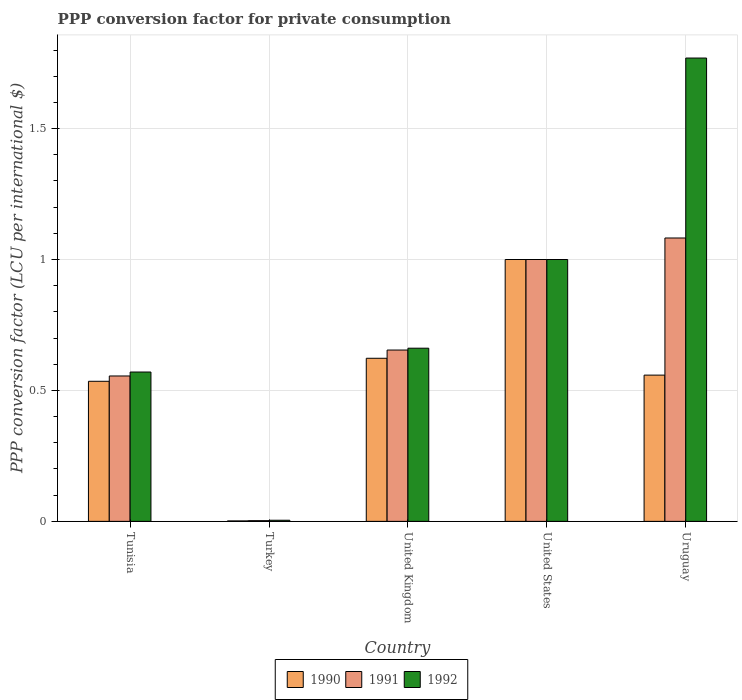Are the number of bars on each tick of the X-axis equal?
Offer a very short reply. Yes. How many bars are there on the 3rd tick from the right?
Your response must be concise. 3. What is the label of the 2nd group of bars from the left?
Your response must be concise. Turkey. What is the PPP conversion factor for private consumption in 1992 in Turkey?
Provide a short and direct response. 0. Across all countries, what is the maximum PPP conversion factor for private consumption in 1991?
Give a very brief answer. 1.08. Across all countries, what is the minimum PPP conversion factor for private consumption in 1990?
Your answer should be compact. 0. In which country was the PPP conversion factor for private consumption in 1992 maximum?
Your response must be concise. Uruguay. In which country was the PPP conversion factor for private consumption in 1992 minimum?
Provide a succinct answer. Turkey. What is the total PPP conversion factor for private consumption in 1992 in the graph?
Give a very brief answer. 4.01. What is the difference between the PPP conversion factor for private consumption in 1990 in Tunisia and that in Turkey?
Keep it short and to the point. 0.53. What is the difference between the PPP conversion factor for private consumption in 1991 in Uruguay and the PPP conversion factor for private consumption in 1992 in United States?
Offer a very short reply. 0.08. What is the average PPP conversion factor for private consumption in 1990 per country?
Your answer should be compact. 0.54. What is the difference between the PPP conversion factor for private consumption of/in 1991 and PPP conversion factor for private consumption of/in 1990 in United States?
Make the answer very short. 0. In how many countries, is the PPP conversion factor for private consumption in 1992 greater than 0.6 LCU?
Provide a short and direct response. 3. What is the ratio of the PPP conversion factor for private consumption in 1991 in Tunisia to that in Uruguay?
Your response must be concise. 0.51. What is the difference between the highest and the second highest PPP conversion factor for private consumption in 1991?
Provide a succinct answer. -0.43. What is the difference between the highest and the lowest PPP conversion factor for private consumption in 1992?
Your response must be concise. 1.77. Is the sum of the PPP conversion factor for private consumption in 1992 in Tunisia and United States greater than the maximum PPP conversion factor for private consumption in 1991 across all countries?
Your answer should be very brief. Yes. What does the 2nd bar from the left in Tunisia represents?
Your answer should be compact. 1991. What does the 1st bar from the right in United States represents?
Keep it short and to the point. 1992. Is it the case that in every country, the sum of the PPP conversion factor for private consumption in 1992 and PPP conversion factor for private consumption in 1991 is greater than the PPP conversion factor for private consumption in 1990?
Offer a terse response. Yes. How many bars are there?
Offer a very short reply. 15. How many countries are there in the graph?
Your answer should be very brief. 5. Does the graph contain any zero values?
Offer a very short reply. No. Where does the legend appear in the graph?
Your answer should be very brief. Bottom center. How many legend labels are there?
Provide a short and direct response. 3. What is the title of the graph?
Your answer should be compact. PPP conversion factor for private consumption. What is the label or title of the X-axis?
Your answer should be very brief. Country. What is the label or title of the Y-axis?
Make the answer very short. PPP conversion factor (LCU per international $). What is the PPP conversion factor (LCU per international $) in 1990 in Tunisia?
Offer a terse response. 0.53. What is the PPP conversion factor (LCU per international $) of 1991 in Tunisia?
Give a very brief answer. 0.56. What is the PPP conversion factor (LCU per international $) in 1992 in Tunisia?
Keep it short and to the point. 0.57. What is the PPP conversion factor (LCU per international $) in 1990 in Turkey?
Make the answer very short. 0. What is the PPP conversion factor (LCU per international $) in 1991 in Turkey?
Keep it short and to the point. 0. What is the PPP conversion factor (LCU per international $) of 1992 in Turkey?
Make the answer very short. 0. What is the PPP conversion factor (LCU per international $) in 1990 in United Kingdom?
Provide a succinct answer. 0.62. What is the PPP conversion factor (LCU per international $) of 1991 in United Kingdom?
Provide a succinct answer. 0.65. What is the PPP conversion factor (LCU per international $) in 1992 in United Kingdom?
Offer a terse response. 0.66. What is the PPP conversion factor (LCU per international $) in 1990 in United States?
Ensure brevity in your answer.  1. What is the PPP conversion factor (LCU per international $) of 1991 in United States?
Your answer should be compact. 1. What is the PPP conversion factor (LCU per international $) in 1992 in United States?
Provide a succinct answer. 1. What is the PPP conversion factor (LCU per international $) in 1990 in Uruguay?
Your answer should be compact. 0.56. What is the PPP conversion factor (LCU per international $) in 1991 in Uruguay?
Make the answer very short. 1.08. What is the PPP conversion factor (LCU per international $) of 1992 in Uruguay?
Offer a terse response. 1.77. Across all countries, what is the maximum PPP conversion factor (LCU per international $) in 1991?
Ensure brevity in your answer.  1.08. Across all countries, what is the maximum PPP conversion factor (LCU per international $) of 1992?
Ensure brevity in your answer.  1.77. Across all countries, what is the minimum PPP conversion factor (LCU per international $) in 1990?
Make the answer very short. 0. Across all countries, what is the minimum PPP conversion factor (LCU per international $) in 1991?
Keep it short and to the point. 0. Across all countries, what is the minimum PPP conversion factor (LCU per international $) of 1992?
Give a very brief answer. 0. What is the total PPP conversion factor (LCU per international $) of 1990 in the graph?
Make the answer very short. 2.72. What is the total PPP conversion factor (LCU per international $) in 1991 in the graph?
Your answer should be very brief. 3.29. What is the total PPP conversion factor (LCU per international $) of 1992 in the graph?
Keep it short and to the point. 4.01. What is the difference between the PPP conversion factor (LCU per international $) in 1990 in Tunisia and that in Turkey?
Provide a succinct answer. 0.53. What is the difference between the PPP conversion factor (LCU per international $) in 1991 in Tunisia and that in Turkey?
Provide a short and direct response. 0.55. What is the difference between the PPP conversion factor (LCU per international $) of 1992 in Tunisia and that in Turkey?
Provide a succinct answer. 0.57. What is the difference between the PPP conversion factor (LCU per international $) of 1990 in Tunisia and that in United Kingdom?
Keep it short and to the point. -0.09. What is the difference between the PPP conversion factor (LCU per international $) of 1991 in Tunisia and that in United Kingdom?
Your response must be concise. -0.1. What is the difference between the PPP conversion factor (LCU per international $) in 1992 in Tunisia and that in United Kingdom?
Make the answer very short. -0.09. What is the difference between the PPP conversion factor (LCU per international $) of 1990 in Tunisia and that in United States?
Make the answer very short. -0.47. What is the difference between the PPP conversion factor (LCU per international $) in 1991 in Tunisia and that in United States?
Your answer should be very brief. -0.44. What is the difference between the PPP conversion factor (LCU per international $) of 1992 in Tunisia and that in United States?
Offer a terse response. -0.43. What is the difference between the PPP conversion factor (LCU per international $) in 1990 in Tunisia and that in Uruguay?
Give a very brief answer. -0.02. What is the difference between the PPP conversion factor (LCU per international $) of 1991 in Tunisia and that in Uruguay?
Your answer should be compact. -0.53. What is the difference between the PPP conversion factor (LCU per international $) of 1992 in Tunisia and that in Uruguay?
Ensure brevity in your answer.  -1.2. What is the difference between the PPP conversion factor (LCU per international $) in 1990 in Turkey and that in United Kingdom?
Your answer should be compact. -0.62. What is the difference between the PPP conversion factor (LCU per international $) of 1991 in Turkey and that in United Kingdom?
Offer a terse response. -0.65. What is the difference between the PPP conversion factor (LCU per international $) in 1992 in Turkey and that in United Kingdom?
Make the answer very short. -0.66. What is the difference between the PPP conversion factor (LCU per international $) in 1990 in Turkey and that in United States?
Ensure brevity in your answer.  -1. What is the difference between the PPP conversion factor (LCU per international $) in 1991 in Turkey and that in United States?
Ensure brevity in your answer.  -1. What is the difference between the PPP conversion factor (LCU per international $) of 1992 in Turkey and that in United States?
Ensure brevity in your answer.  -1. What is the difference between the PPP conversion factor (LCU per international $) in 1990 in Turkey and that in Uruguay?
Give a very brief answer. -0.56. What is the difference between the PPP conversion factor (LCU per international $) in 1991 in Turkey and that in Uruguay?
Offer a very short reply. -1.08. What is the difference between the PPP conversion factor (LCU per international $) in 1992 in Turkey and that in Uruguay?
Keep it short and to the point. -1.76. What is the difference between the PPP conversion factor (LCU per international $) in 1990 in United Kingdom and that in United States?
Your answer should be compact. -0.38. What is the difference between the PPP conversion factor (LCU per international $) of 1991 in United Kingdom and that in United States?
Your answer should be very brief. -0.35. What is the difference between the PPP conversion factor (LCU per international $) in 1992 in United Kingdom and that in United States?
Your response must be concise. -0.34. What is the difference between the PPP conversion factor (LCU per international $) in 1990 in United Kingdom and that in Uruguay?
Provide a succinct answer. 0.06. What is the difference between the PPP conversion factor (LCU per international $) of 1991 in United Kingdom and that in Uruguay?
Provide a succinct answer. -0.43. What is the difference between the PPP conversion factor (LCU per international $) of 1992 in United Kingdom and that in Uruguay?
Provide a succinct answer. -1.11. What is the difference between the PPP conversion factor (LCU per international $) in 1990 in United States and that in Uruguay?
Your response must be concise. 0.44. What is the difference between the PPP conversion factor (LCU per international $) of 1991 in United States and that in Uruguay?
Give a very brief answer. -0.08. What is the difference between the PPP conversion factor (LCU per international $) of 1992 in United States and that in Uruguay?
Your answer should be very brief. -0.77. What is the difference between the PPP conversion factor (LCU per international $) of 1990 in Tunisia and the PPP conversion factor (LCU per international $) of 1991 in Turkey?
Your response must be concise. 0.53. What is the difference between the PPP conversion factor (LCU per international $) of 1990 in Tunisia and the PPP conversion factor (LCU per international $) of 1992 in Turkey?
Provide a succinct answer. 0.53. What is the difference between the PPP conversion factor (LCU per international $) of 1991 in Tunisia and the PPP conversion factor (LCU per international $) of 1992 in Turkey?
Provide a short and direct response. 0.55. What is the difference between the PPP conversion factor (LCU per international $) in 1990 in Tunisia and the PPP conversion factor (LCU per international $) in 1991 in United Kingdom?
Offer a terse response. -0.12. What is the difference between the PPP conversion factor (LCU per international $) in 1990 in Tunisia and the PPP conversion factor (LCU per international $) in 1992 in United Kingdom?
Make the answer very short. -0.13. What is the difference between the PPP conversion factor (LCU per international $) of 1991 in Tunisia and the PPP conversion factor (LCU per international $) of 1992 in United Kingdom?
Your response must be concise. -0.11. What is the difference between the PPP conversion factor (LCU per international $) in 1990 in Tunisia and the PPP conversion factor (LCU per international $) in 1991 in United States?
Offer a very short reply. -0.47. What is the difference between the PPP conversion factor (LCU per international $) of 1990 in Tunisia and the PPP conversion factor (LCU per international $) of 1992 in United States?
Your response must be concise. -0.47. What is the difference between the PPP conversion factor (LCU per international $) in 1991 in Tunisia and the PPP conversion factor (LCU per international $) in 1992 in United States?
Your answer should be very brief. -0.44. What is the difference between the PPP conversion factor (LCU per international $) of 1990 in Tunisia and the PPP conversion factor (LCU per international $) of 1991 in Uruguay?
Make the answer very short. -0.55. What is the difference between the PPP conversion factor (LCU per international $) in 1990 in Tunisia and the PPP conversion factor (LCU per international $) in 1992 in Uruguay?
Make the answer very short. -1.23. What is the difference between the PPP conversion factor (LCU per international $) in 1991 in Tunisia and the PPP conversion factor (LCU per international $) in 1992 in Uruguay?
Your response must be concise. -1.21. What is the difference between the PPP conversion factor (LCU per international $) in 1990 in Turkey and the PPP conversion factor (LCU per international $) in 1991 in United Kingdom?
Keep it short and to the point. -0.65. What is the difference between the PPP conversion factor (LCU per international $) of 1990 in Turkey and the PPP conversion factor (LCU per international $) of 1992 in United Kingdom?
Make the answer very short. -0.66. What is the difference between the PPP conversion factor (LCU per international $) of 1991 in Turkey and the PPP conversion factor (LCU per international $) of 1992 in United Kingdom?
Offer a very short reply. -0.66. What is the difference between the PPP conversion factor (LCU per international $) of 1990 in Turkey and the PPP conversion factor (LCU per international $) of 1991 in United States?
Offer a very short reply. -1. What is the difference between the PPP conversion factor (LCU per international $) of 1990 in Turkey and the PPP conversion factor (LCU per international $) of 1992 in United States?
Provide a succinct answer. -1. What is the difference between the PPP conversion factor (LCU per international $) of 1991 in Turkey and the PPP conversion factor (LCU per international $) of 1992 in United States?
Make the answer very short. -1. What is the difference between the PPP conversion factor (LCU per international $) in 1990 in Turkey and the PPP conversion factor (LCU per international $) in 1991 in Uruguay?
Offer a very short reply. -1.08. What is the difference between the PPP conversion factor (LCU per international $) of 1990 in Turkey and the PPP conversion factor (LCU per international $) of 1992 in Uruguay?
Your answer should be compact. -1.77. What is the difference between the PPP conversion factor (LCU per international $) of 1991 in Turkey and the PPP conversion factor (LCU per international $) of 1992 in Uruguay?
Ensure brevity in your answer.  -1.77. What is the difference between the PPP conversion factor (LCU per international $) in 1990 in United Kingdom and the PPP conversion factor (LCU per international $) in 1991 in United States?
Make the answer very short. -0.38. What is the difference between the PPP conversion factor (LCU per international $) in 1990 in United Kingdom and the PPP conversion factor (LCU per international $) in 1992 in United States?
Offer a terse response. -0.38. What is the difference between the PPP conversion factor (LCU per international $) of 1991 in United Kingdom and the PPP conversion factor (LCU per international $) of 1992 in United States?
Your answer should be compact. -0.35. What is the difference between the PPP conversion factor (LCU per international $) of 1990 in United Kingdom and the PPP conversion factor (LCU per international $) of 1991 in Uruguay?
Keep it short and to the point. -0.46. What is the difference between the PPP conversion factor (LCU per international $) of 1990 in United Kingdom and the PPP conversion factor (LCU per international $) of 1992 in Uruguay?
Provide a short and direct response. -1.15. What is the difference between the PPP conversion factor (LCU per international $) of 1991 in United Kingdom and the PPP conversion factor (LCU per international $) of 1992 in Uruguay?
Provide a short and direct response. -1.12. What is the difference between the PPP conversion factor (LCU per international $) in 1990 in United States and the PPP conversion factor (LCU per international $) in 1991 in Uruguay?
Provide a succinct answer. -0.08. What is the difference between the PPP conversion factor (LCU per international $) of 1990 in United States and the PPP conversion factor (LCU per international $) of 1992 in Uruguay?
Your answer should be very brief. -0.77. What is the difference between the PPP conversion factor (LCU per international $) of 1991 in United States and the PPP conversion factor (LCU per international $) of 1992 in Uruguay?
Make the answer very short. -0.77. What is the average PPP conversion factor (LCU per international $) in 1990 per country?
Your response must be concise. 0.54. What is the average PPP conversion factor (LCU per international $) of 1991 per country?
Ensure brevity in your answer.  0.66. What is the average PPP conversion factor (LCU per international $) in 1992 per country?
Give a very brief answer. 0.8. What is the difference between the PPP conversion factor (LCU per international $) of 1990 and PPP conversion factor (LCU per international $) of 1991 in Tunisia?
Provide a short and direct response. -0.02. What is the difference between the PPP conversion factor (LCU per international $) in 1990 and PPP conversion factor (LCU per international $) in 1992 in Tunisia?
Keep it short and to the point. -0.04. What is the difference between the PPP conversion factor (LCU per international $) in 1991 and PPP conversion factor (LCU per international $) in 1992 in Tunisia?
Your answer should be compact. -0.02. What is the difference between the PPP conversion factor (LCU per international $) of 1990 and PPP conversion factor (LCU per international $) of 1991 in Turkey?
Keep it short and to the point. -0. What is the difference between the PPP conversion factor (LCU per international $) of 1990 and PPP conversion factor (LCU per international $) of 1992 in Turkey?
Offer a terse response. -0. What is the difference between the PPP conversion factor (LCU per international $) of 1991 and PPP conversion factor (LCU per international $) of 1992 in Turkey?
Your response must be concise. -0. What is the difference between the PPP conversion factor (LCU per international $) of 1990 and PPP conversion factor (LCU per international $) of 1991 in United Kingdom?
Keep it short and to the point. -0.03. What is the difference between the PPP conversion factor (LCU per international $) in 1990 and PPP conversion factor (LCU per international $) in 1992 in United Kingdom?
Offer a very short reply. -0.04. What is the difference between the PPP conversion factor (LCU per international $) in 1991 and PPP conversion factor (LCU per international $) in 1992 in United Kingdom?
Offer a very short reply. -0.01. What is the difference between the PPP conversion factor (LCU per international $) of 1990 and PPP conversion factor (LCU per international $) of 1991 in Uruguay?
Offer a very short reply. -0.52. What is the difference between the PPP conversion factor (LCU per international $) in 1990 and PPP conversion factor (LCU per international $) in 1992 in Uruguay?
Offer a very short reply. -1.21. What is the difference between the PPP conversion factor (LCU per international $) of 1991 and PPP conversion factor (LCU per international $) of 1992 in Uruguay?
Provide a short and direct response. -0.69. What is the ratio of the PPP conversion factor (LCU per international $) of 1990 in Tunisia to that in Turkey?
Offer a terse response. 312.81. What is the ratio of the PPP conversion factor (LCU per international $) of 1991 in Tunisia to that in Turkey?
Your answer should be compact. 208.65. What is the ratio of the PPP conversion factor (LCU per international $) in 1992 in Tunisia to that in Turkey?
Give a very brief answer. 132.9. What is the ratio of the PPP conversion factor (LCU per international $) of 1990 in Tunisia to that in United Kingdom?
Offer a terse response. 0.86. What is the ratio of the PPP conversion factor (LCU per international $) of 1991 in Tunisia to that in United Kingdom?
Make the answer very short. 0.85. What is the ratio of the PPP conversion factor (LCU per international $) of 1992 in Tunisia to that in United Kingdom?
Offer a very short reply. 0.86. What is the ratio of the PPP conversion factor (LCU per international $) of 1990 in Tunisia to that in United States?
Your answer should be compact. 0.53. What is the ratio of the PPP conversion factor (LCU per international $) in 1991 in Tunisia to that in United States?
Make the answer very short. 0.56. What is the ratio of the PPP conversion factor (LCU per international $) of 1992 in Tunisia to that in United States?
Your answer should be very brief. 0.57. What is the ratio of the PPP conversion factor (LCU per international $) of 1990 in Tunisia to that in Uruguay?
Your answer should be compact. 0.96. What is the ratio of the PPP conversion factor (LCU per international $) in 1991 in Tunisia to that in Uruguay?
Your answer should be very brief. 0.51. What is the ratio of the PPP conversion factor (LCU per international $) of 1992 in Tunisia to that in Uruguay?
Offer a very short reply. 0.32. What is the ratio of the PPP conversion factor (LCU per international $) of 1990 in Turkey to that in United Kingdom?
Provide a succinct answer. 0. What is the ratio of the PPP conversion factor (LCU per international $) of 1991 in Turkey to that in United Kingdom?
Provide a succinct answer. 0. What is the ratio of the PPP conversion factor (LCU per international $) of 1992 in Turkey to that in United Kingdom?
Make the answer very short. 0.01. What is the ratio of the PPP conversion factor (LCU per international $) in 1990 in Turkey to that in United States?
Make the answer very short. 0. What is the ratio of the PPP conversion factor (LCU per international $) of 1991 in Turkey to that in United States?
Give a very brief answer. 0. What is the ratio of the PPP conversion factor (LCU per international $) of 1992 in Turkey to that in United States?
Provide a short and direct response. 0. What is the ratio of the PPP conversion factor (LCU per international $) in 1990 in Turkey to that in Uruguay?
Your answer should be compact. 0. What is the ratio of the PPP conversion factor (LCU per international $) in 1991 in Turkey to that in Uruguay?
Offer a terse response. 0. What is the ratio of the PPP conversion factor (LCU per international $) of 1992 in Turkey to that in Uruguay?
Offer a very short reply. 0. What is the ratio of the PPP conversion factor (LCU per international $) of 1990 in United Kingdom to that in United States?
Provide a short and direct response. 0.62. What is the ratio of the PPP conversion factor (LCU per international $) of 1991 in United Kingdom to that in United States?
Keep it short and to the point. 0.65. What is the ratio of the PPP conversion factor (LCU per international $) in 1992 in United Kingdom to that in United States?
Provide a short and direct response. 0.66. What is the ratio of the PPP conversion factor (LCU per international $) in 1990 in United Kingdom to that in Uruguay?
Make the answer very short. 1.12. What is the ratio of the PPP conversion factor (LCU per international $) of 1991 in United Kingdom to that in Uruguay?
Ensure brevity in your answer.  0.6. What is the ratio of the PPP conversion factor (LCU per international $) of 1992 in United Kingdom to that in Uruguay?
Ensure brevity in your answer.  0.37. What is the ratio of the PPP conversion factor (LCU per international $) of 1990 in United States to that in Uruguay?
Provide a short and direct response. 1.79. What is the ratio of the PPP conversion factor (LCU per international $) in 1991 in United States to that in Uruguay?
Offer a terse response. 0.92. What is the ratio of the PPP conversion factor (LCU per international $) of 1992 in United States to that in Uruguay?
Your response must be concise. 0.57. What is the difference between the highest and the second highest PPP conversion factor (LCU per international $) in 1990?
Provide a short and direct response. 0.38. What is the difference between the highest and the second highest PPP conversion factor (LCU per international $) in 1991?
Make the answer very short. 0.08. What is the difference between the highest and the second highest PPP conversion factor (LCU per international $) in 1992?
Provide a short and direct response. 0.77. What is the difference between the highest and the lowest PPP conversion factor (LCU per international $) of 1990?
Offer a terse response. 1. What is the difference between the highest and the lowest PPP conversion factor (LCU per international $) of 1991?
Offer a terse response. 1.08. What is the difference between the highest and the lowest PPP conversion factor (LCU per international $) in 1992?
Offer a very short reply. 1.76. 